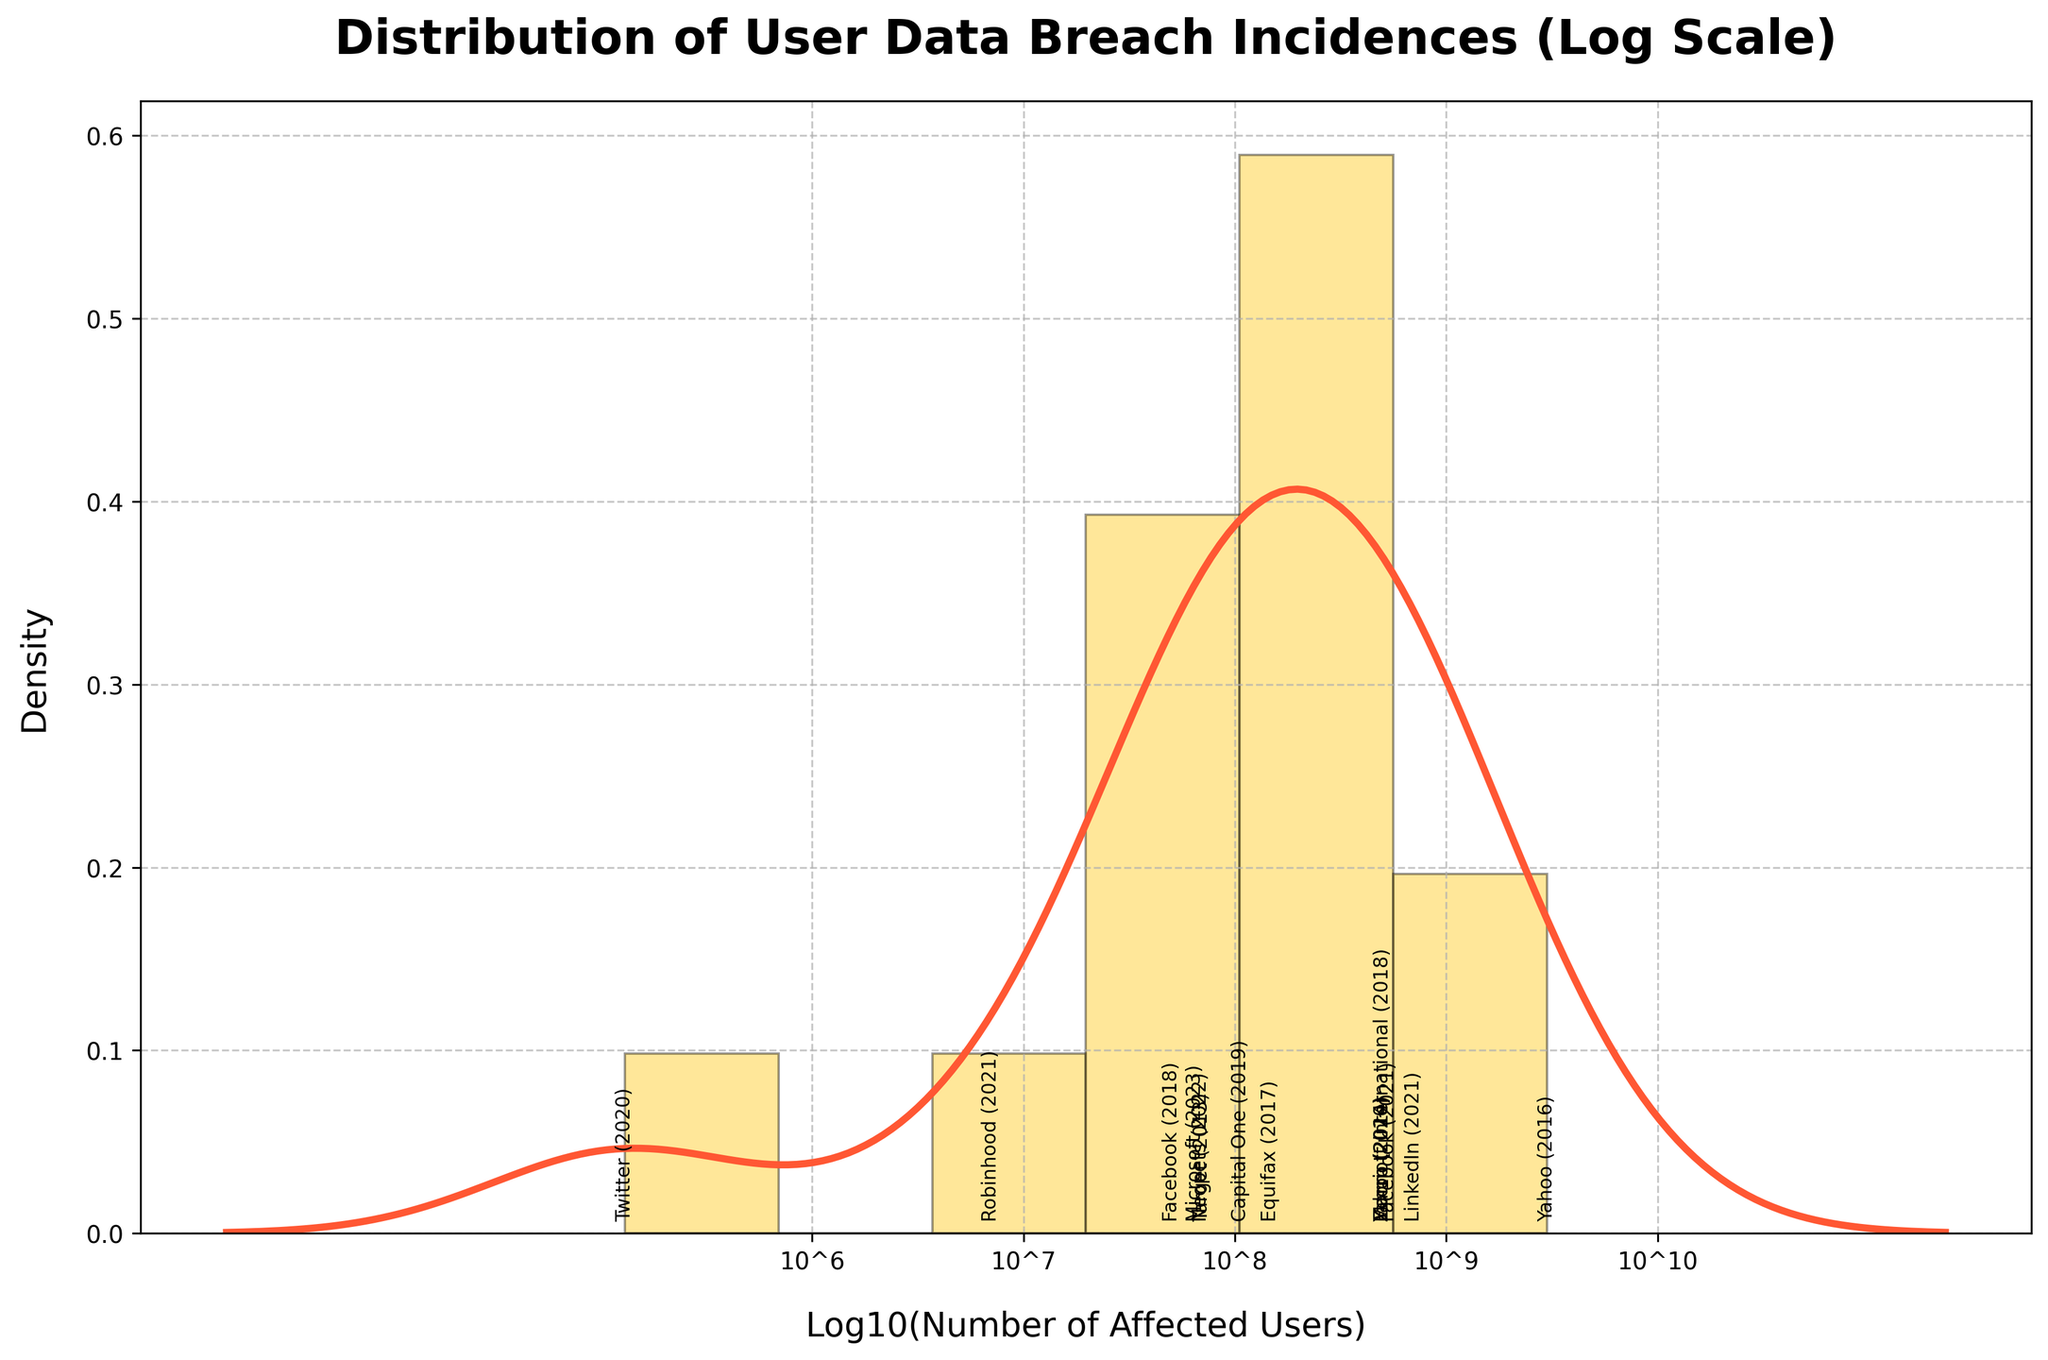What is the title of the figure? The title is generally found at the top of the figure and is designed to give a brief description of the plot.
Answer: Distribution of User Data Breach Incidences (Log Scale) What does the x-axis represent? By examining the axis label, we can determine what the x-axis represents in the plot.
Answer: Log10(Number of Affected Users) How many distinct data points are annotated on the x-axis? Annotated data points will usually have text labels referencing specific values or events. You can count these annotations by looking at the plot.
Answer: 13 Which company had a data breach incidence exceeding one billion affected users? Reviewing the annotations for specific companies and their associated years and comparing the values against one billion will help determine the answer.
Answer: Yahoo Which years show data breach incidences for Facebook? By looking at the annotations associated with Facebook and noting down the corresponding years, we can determine the answer.
Answer: 2018, 2021 Which company had the lowest number of affected users and in which year? Identifying the minimum value on the x-axis and tracing back to the annotation will provide the company and year.
Answer: Twitter, 2020 What is the most common log scale interval shown on the x-axis? Reviewing the tick marks and their labels will allow us to determine the most common interval between the marks.
Answer: 10^6 to 10^10 What does the y-axis represent in this plot? The y-axis label provides information about what is being measured on that axis.
Answer: Density Which year had the highest number of data breach incidences in the plot? By examining all the annotations, you can identify the year with the largest value on the x-axis.
Answer: 2016 Comparing Yahoo’s largest data breach and Facebook’s largest data breach, which one had more affected users? Locate and compare the annotations for Yahoo and Facebook to determine which breach had more affected users.
Answer: Yahoo 